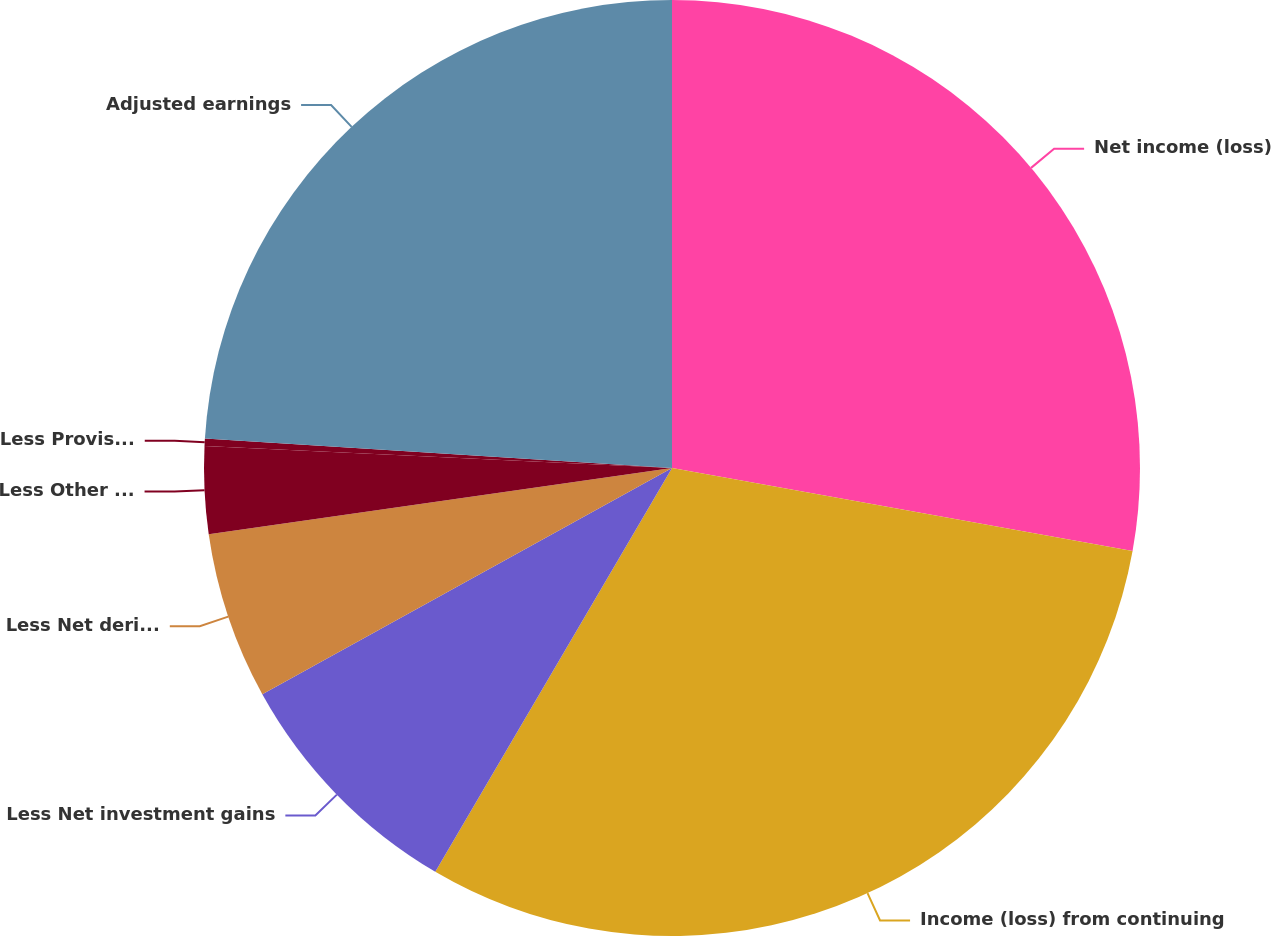Convert chart to OTSL. <chart><loc_0><loc_0><loc_500><loc_500><pie_chart><fcel>Net income (loss)<fcel>Income (loss) from continuing<fcel>Less Net investment gains<fcel>Less Net derivative gains<fcel>Less Other adjustments to<fcel>Less Provision for income tax<fcel>Adjusted earnings<nl><fcel>27.84%<fcel>30.6%<fcel>8.53%<fcel>5.77%<fcel>3.01%<fcel>0.25%<fcel>24.0%<nl></chart> 